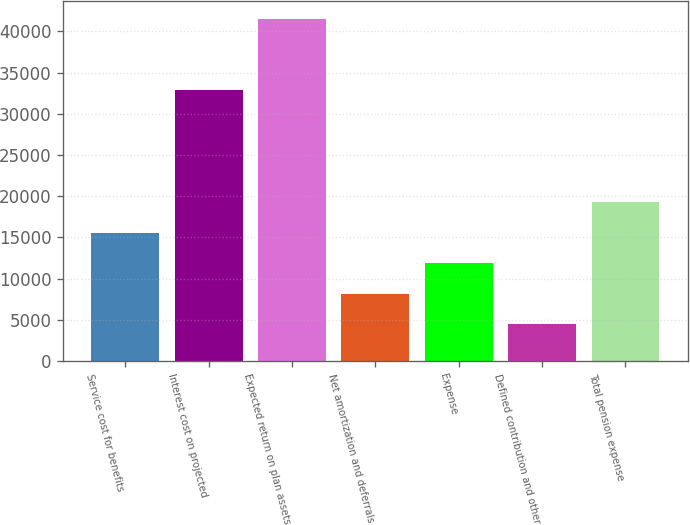Convert chart to OTSL. <chart><loc_0><loc_0><loc_500><loc_500><bar_chart><fcel>Service cost for benefits<fcel>Interest cost on projected<fcel>Expected return on plan assets<fcel>Net amortization and deferrals<fcel>Expense<fcel>Defined contribution and other<fcel>Total pension expense<nl><fcel>15592<fcel>32954<fcel>41569<fcel>8170<fcel>11881<fcel>4459<fcel>19303<nl></chart> 